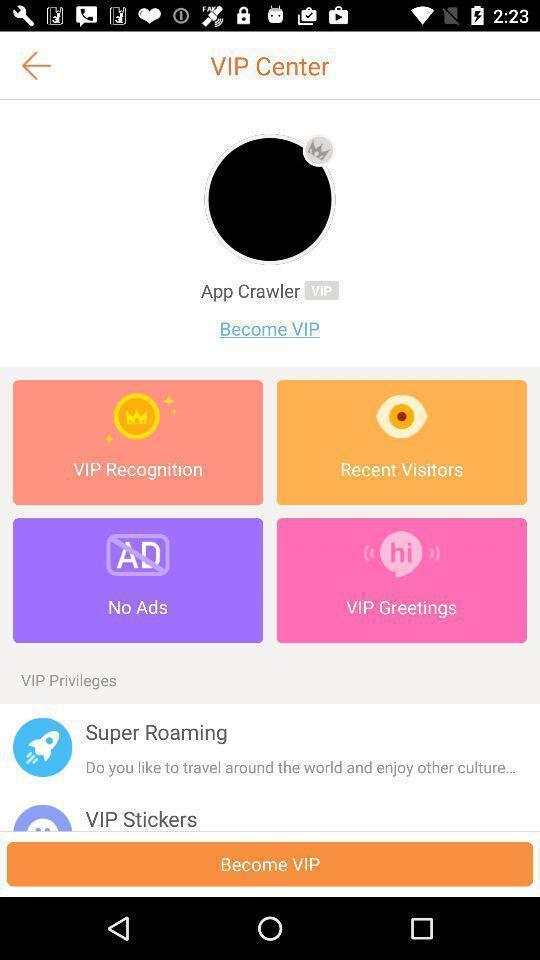Give me a summary of this screen capture. Screen showing vip center with options. 